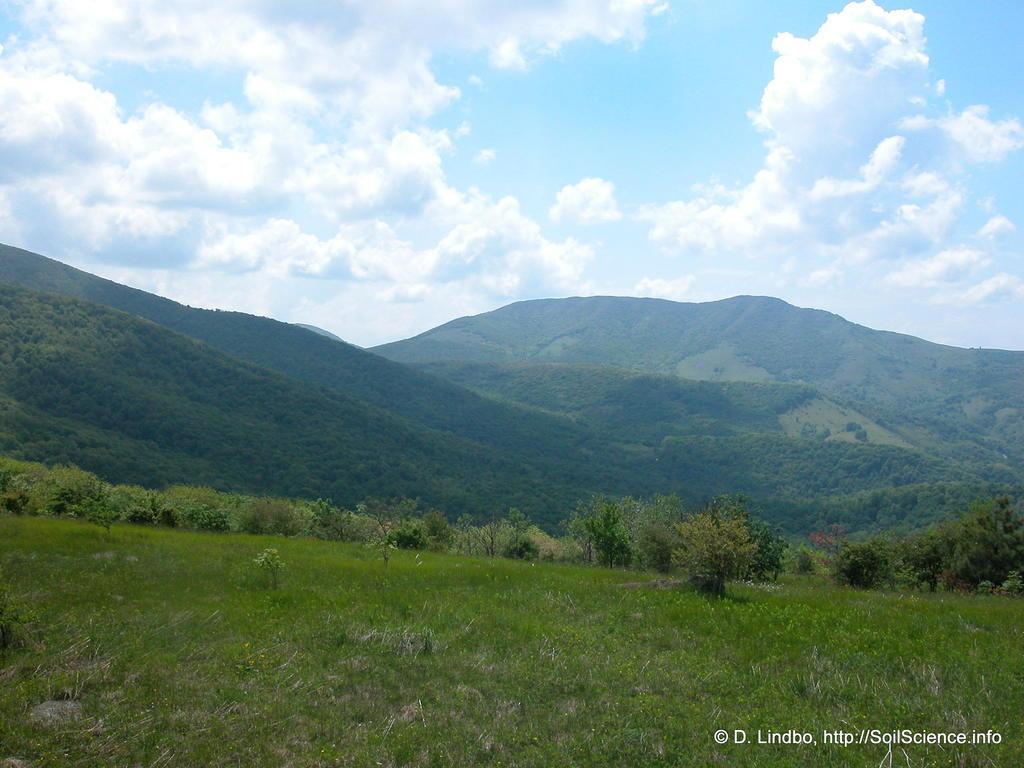Please provide a concise description of this image. In this image there is grass at the bottom. There are trees and mountains in the background. There is sky at the top. 